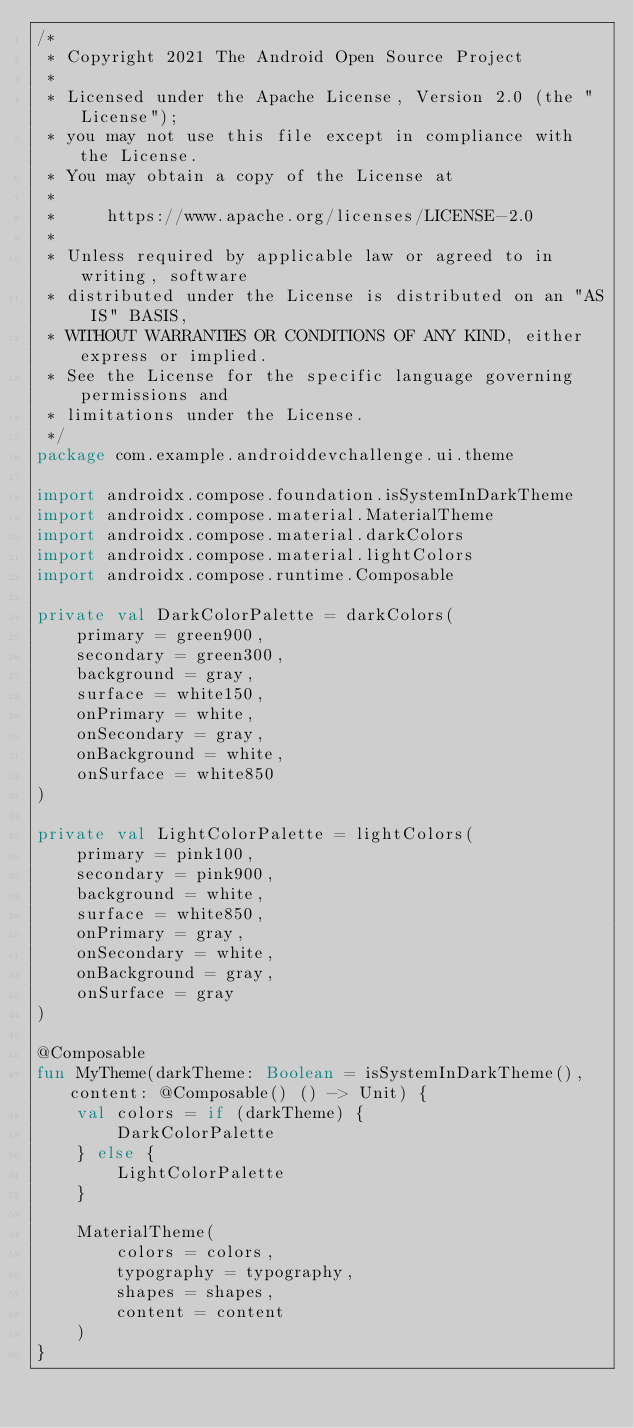<code> <loc_0><loc_0><loc_500><loc_500><_Kotlin_>/*
 * Copyright 2021 The Android Open Source Project
 *
 * Licensed under the Apache License, Version 2.0 (the "License");
 * you may not use this file except in compliance with the License.
 * You may obtain a copy of the License at
 *
 *     https://www.apache.org/licenses/LICENSE-2.0
 *
 * Unless required by applicable law or agreed to in writing, software
 * distributed under the License is distributed on an "AS IS" BASIS,
 * WITHOUT WARRANTIES OR CONDITIONS OF ANY KIND, either express or implied.
 * See the License for the specific language governing permissions and
 * limitations under the License.
 */
package com.example.androiddevchallenge.ui.theme

import androidx.compose.foundation.isSystemInDarkTheme
import androidx.compose.material.MaterialTheme
import androidx.compose.material.darkColors
import androidx.compose.material.lightColors
import androidx.compose.runtime.Composable

private val DarkColorPalette = darkColors(
    primary = green900,
    secondary = green300,
    background = gray,
    surface = white150,
    onPrimary = white,
    onSecondary = gray,
    onBackground = white,
    onSurface = white850
)

private val LightColorPalette = lightColors(
    primary = pink100,
    secondary = pink900,
    background = white,
    surface = white850,
    onPrimary = gray,
    onSecondary = white,
    onBackground = gray,
    onSurface = gray
)

@Composable
fun MyTheme(darkTheme: Boolean = isSystemInDarkTheme(), content: @Composable() () -> Unit) {
    val colors = if (darkTheme) {
        DarkColorPalette
    } else {
        LightColorPalette
    }

    MaterialTheme(
        colors = colors,
        typography = typography,
        shapes = shapes,
        content = content
    )
}
</code> 